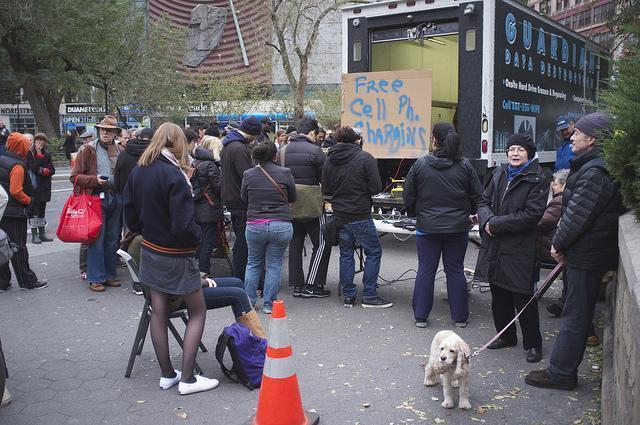How many trucks can be seen?
Give a very brief answer. 1. How many people are there?
Give a very brief answer. 12. 